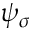Convert formula to latex. <formula><loc_0><loc_0><loc_500><loc_500>\psi _ { \sigma }</formula> 